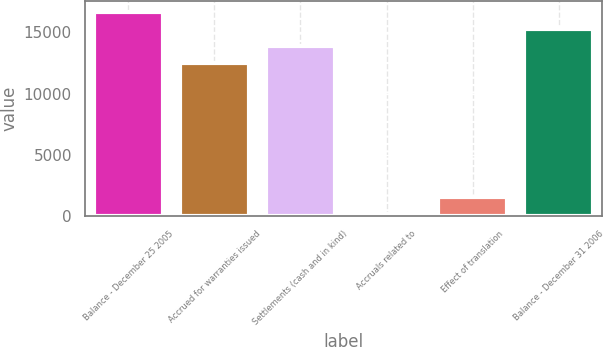Convert chart. <chart><loc_0><loc_0><loc_500><loc_500><bar_chart><fcel>Balance - December 25 2005<fcel>Accrued for warranties issued<fcel>Settlements (cash and in kind)<fcel>Accruals related to<fcel>Effect of translation<fcel>Balance - December 31 2006<nl><fcel>16706.9<fcel>12503<fcel>13904.3<fcel>143<fcel>1544.3<fcel>15305.6<nl></chart> 